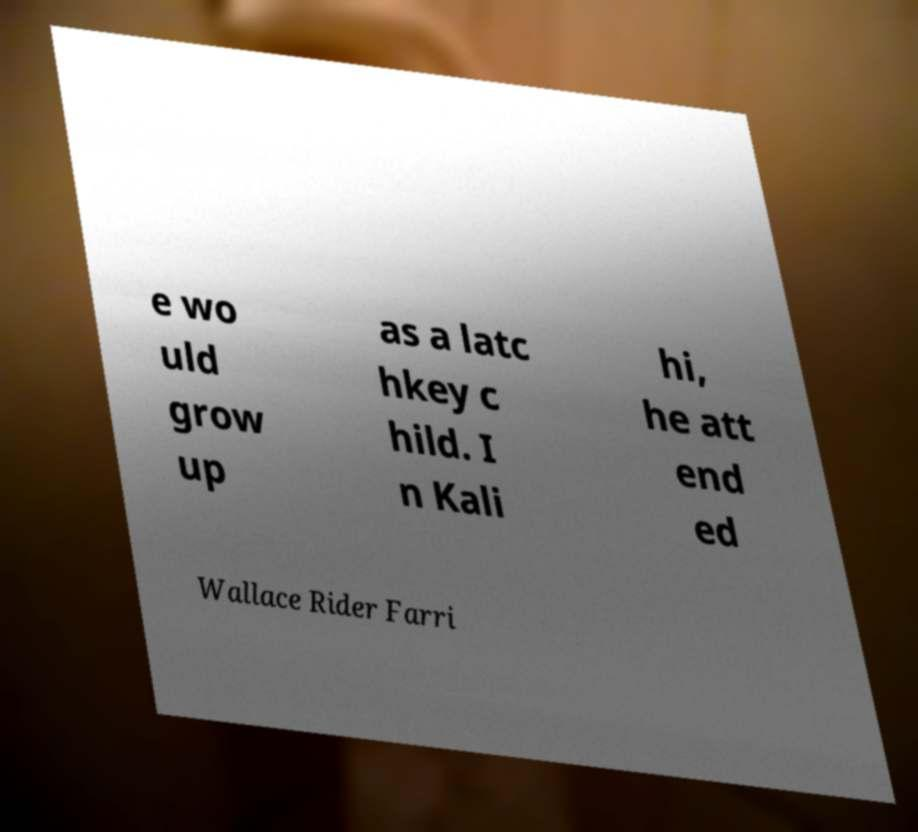For documentation purposes, I need the text within this image transcribed. Could you provide that? e wo uld grow up as a latc hkey c hild. I n Kali hi, he att end ed Wallace Rider Farri 